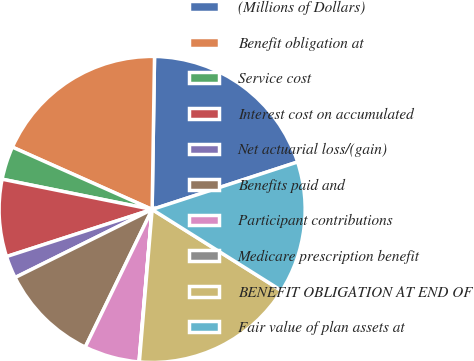Convert chart. <chart><loc_0><loc_0><loc_500><loc_500><pie_chart><fcel>(Millions of Dollars)<fcel>Benefit obligation at<fcel>Service cost<fcel>Interest cost on accumulated<fcel>Net actuarial loss/(gain)<fcel>Benefits paid and<fcel>Participant contributions<fcel>Medicare prescription benefit<fcel>BENEFIT OBLIGATION AT END OF<fcel>Fair value of plan assets at<nl><fcel>19.73%<fcel>18.57%<fcel>3.51%<fcel>8.15%<fcel>2.36%<fcel>10.46%<fcel>5.83%<fcel>0.04%<fcel>17.41%<fcel>13.94%<nl></chart> 